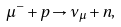<formula> <loc_0><loc_0><loc_500><loc_500>\mu ^ { - } + p \rightarrow \nu _ { \mu } + n ,</formula> 